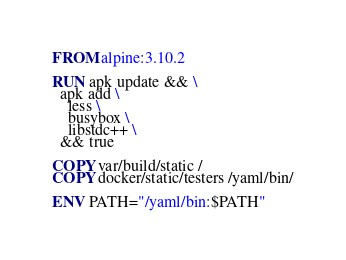<code> <loc_0><loc_0><loc_500><loc_500><_Dockerfile_>FROM alpine:3.10.2

RUN apk update && \
  apk add \
    less \
    busybox \
    libstdc++ \
  && true

COPY var/build/static /
COPY docker/static/testers /yaml/bin/

ENV PATH="/yaml/bin:$PATH"
</code> 